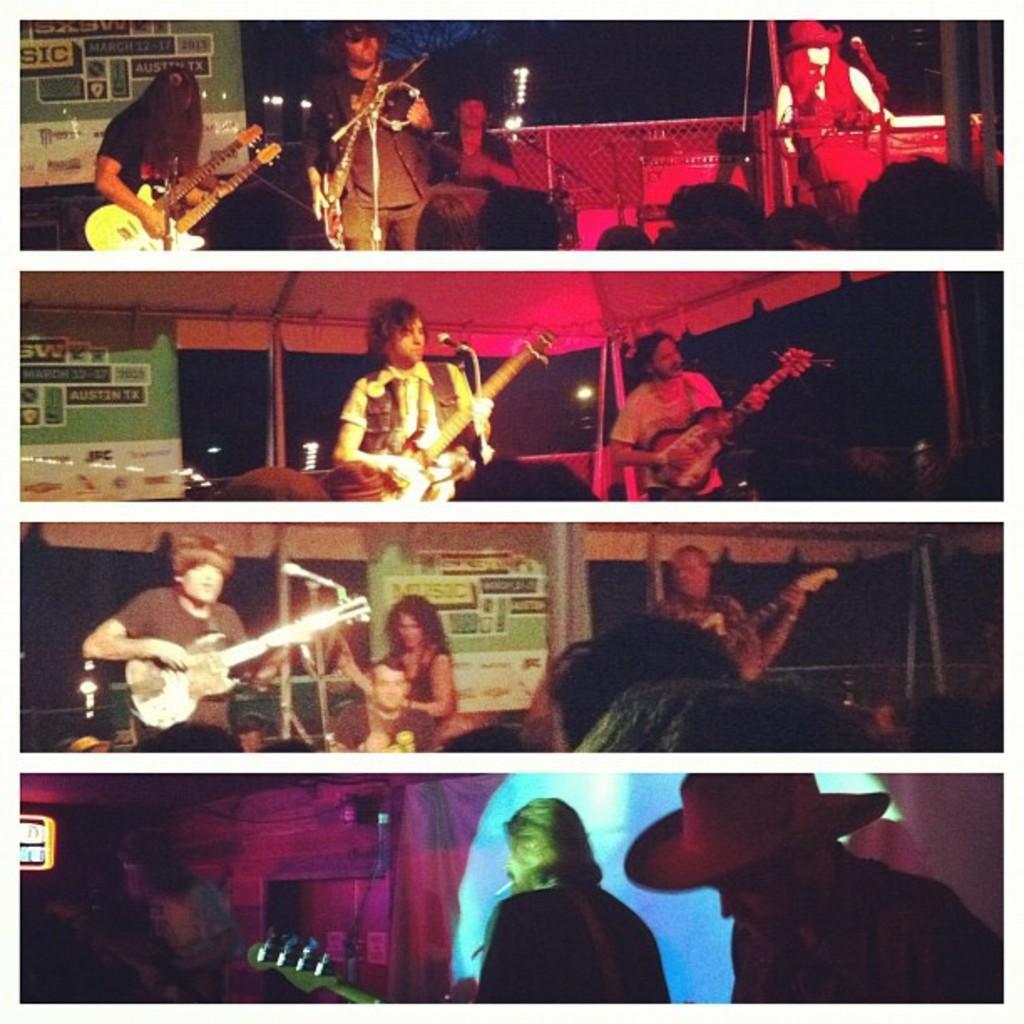Can you describe this image briefly? This is a collage image of a few people who are playing with musical instruments. 